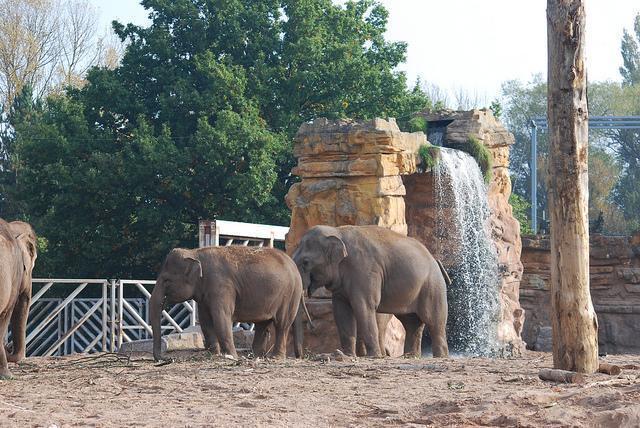What is near the elephants?
From the following four choices, select the correct answer to address the question.
Options: Drones, toddlers, eggs, trees. Trees. 